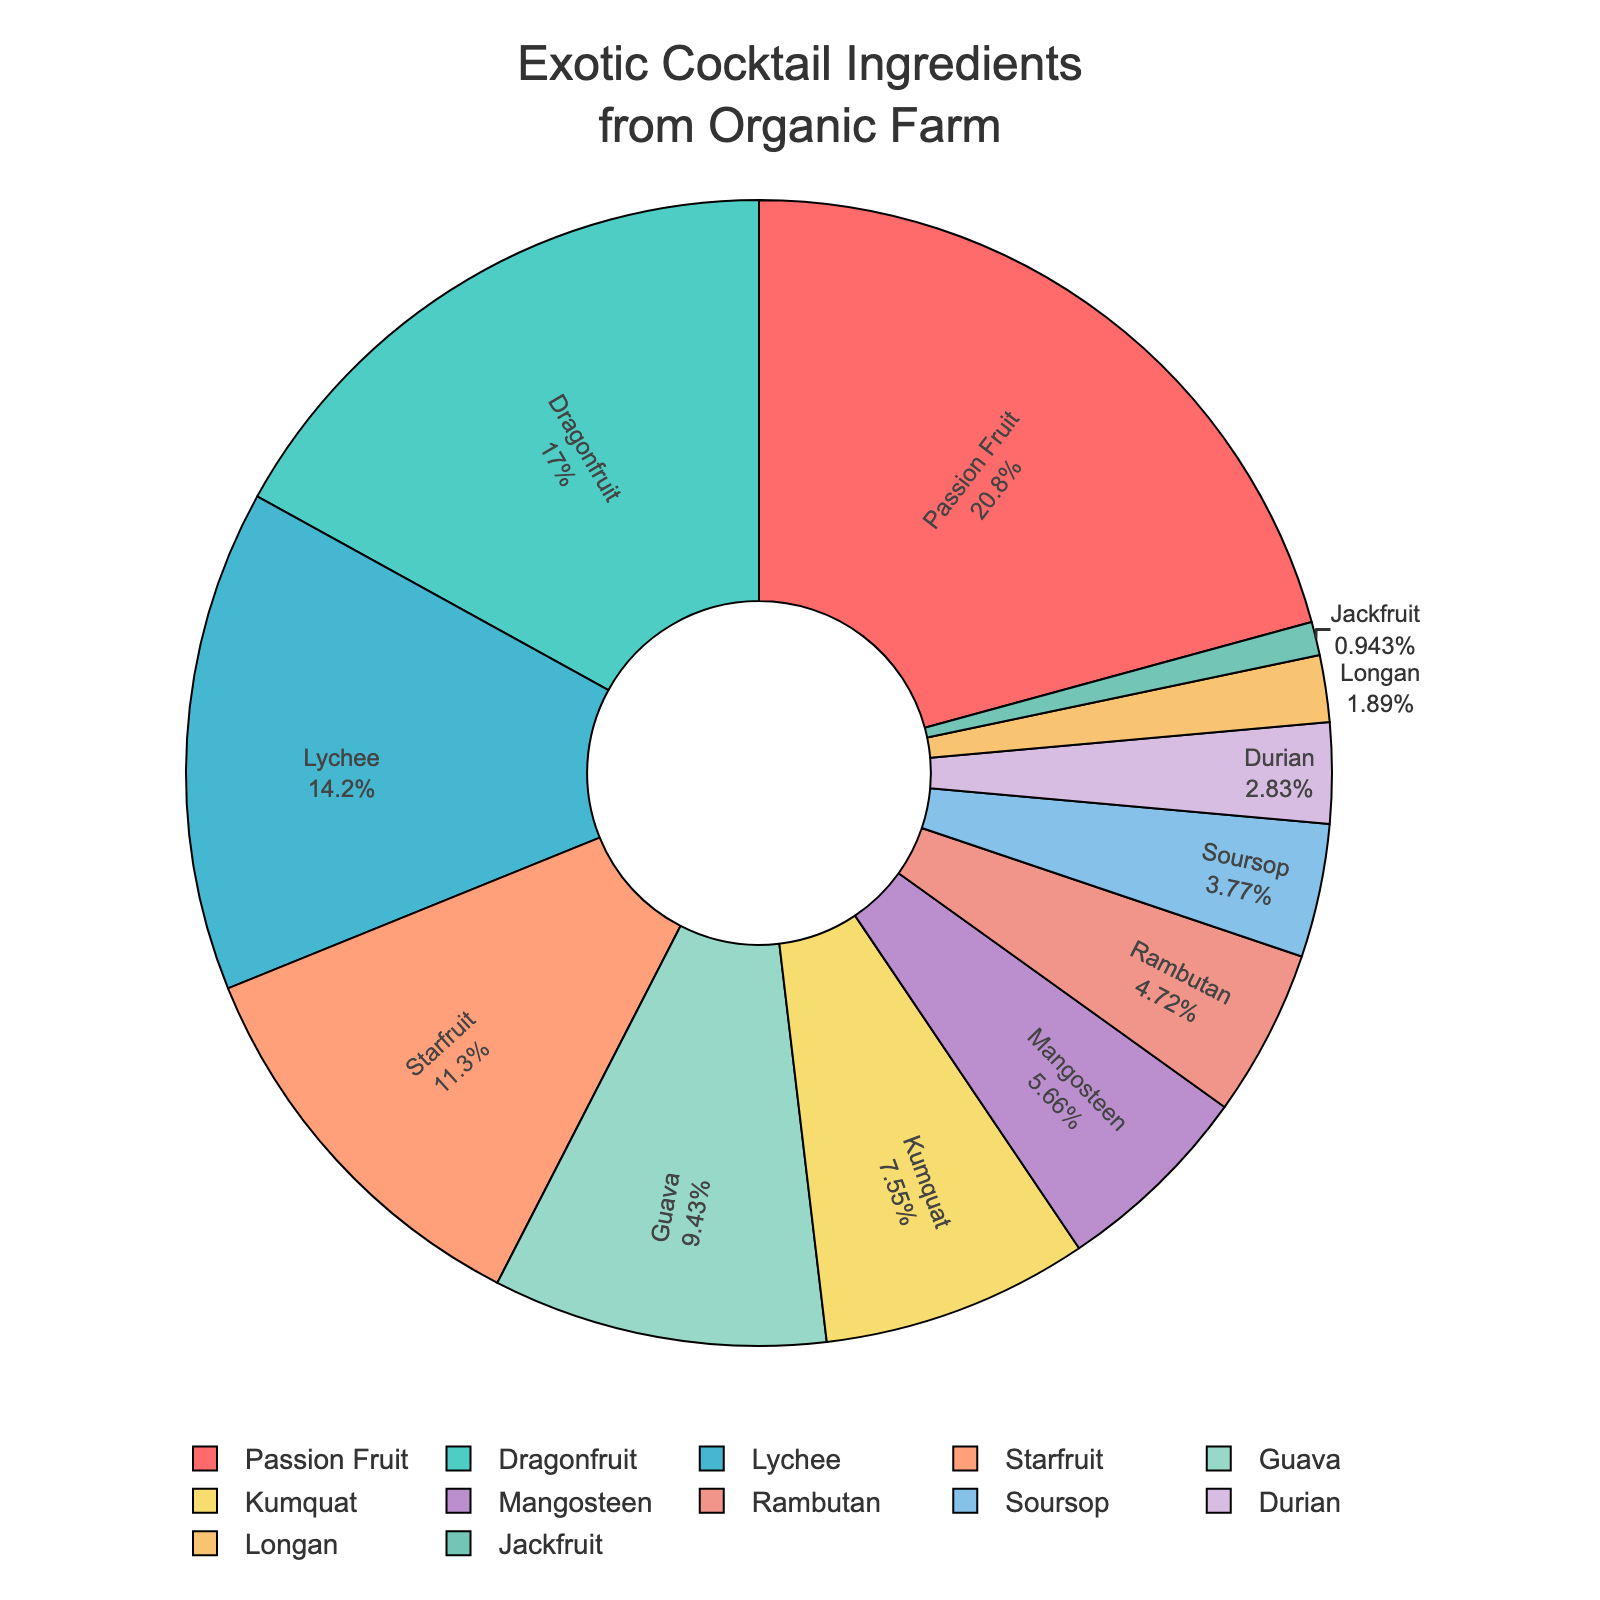Which ingredient has the highest percentage? To find the ingredient with the highest percentage, look at the pie chart and identify the segment with the largest size. The labels and percentages displayed within the segments help confirm this.
Answer: Passion Fruit How many ingredients have percentages less than 10%? Check each segment in the pie chart and count the number of ingredients with percentages labeled as less than 10%.
Answer: 7 What is the combined percentage of Passion Fruit, Dragonfruit, and Lychee? Locate the percentages for Passion Fruit, Dragonfruit, and Lychee on the pie chart (22%, 18%, 15%). Sum these percentages: 22% + 18% + 15% = 55%.
Answer: 55% Which ingredient has a larger percentage: Mangosteen or Rambutan? Compare the segments corresponding to Mangosteen and Rambutan. Mangosteen is labeled as 6% and Rambutan as 5%. Mangosteen is larger.
Answer: Mangosteen What is the difference in percentage between the ingredient with the highest percentage and the ingredient with the lowest percentage? Identify the highest and lowest percentages in the pie chart. The highest is Passion Fruit at 22% and the lowest is Jackfruit at 1%. Calculate the difference: 22% - 1% = 21%.
Answer: 21% What is the average percentage of all ingredients listed? Sum all the percentages given in the data (22 + 18 + 15 + 12 + 10 + 8 + 6 + 5 + 4 + 3 + 2 + 1 = 106). There are 12 ingredients, so the average is 106 / 12 = 8.83%.
Answer: 8.83% Which three ingredients have the lowest percentages and what is their combined proportion? Find the three segments with the smallest sizes: Jackfruit (1%), Longan (2%), and Durian (3%). Sum these percentages: 1% + 2% + 3% = 6%.
Answer: 6% If Passion Fruit’s percentage were to decrease by 5% and be evenly distributed among all other ingredients, what would the new percentage of Dragonfruit be? Passion Fruit's current percentage is 22%. Decreasing by 5% results in 22% - 5% = 17%. The 5% decrease is distributed evenly among 11 remaining ingredients, each getting 5% / 11 = 0.45%. Dragonfruit's new percentage is 18% + 0.45% = 18.45%.
Answer: 18.45% What is the median percentage value among all the ingredients? Arrange the percentages in ascending order: 1, 2, 3, 4, 5, 6, 8, 10, 12, 15, 18, 22. Since there are 12 values, the median is the average of the 6th and 7th values. The 6th value is 6% and the 7th is 8%, so the median is (6% + 8%) / 2 = 7%.
Answer: 7% 